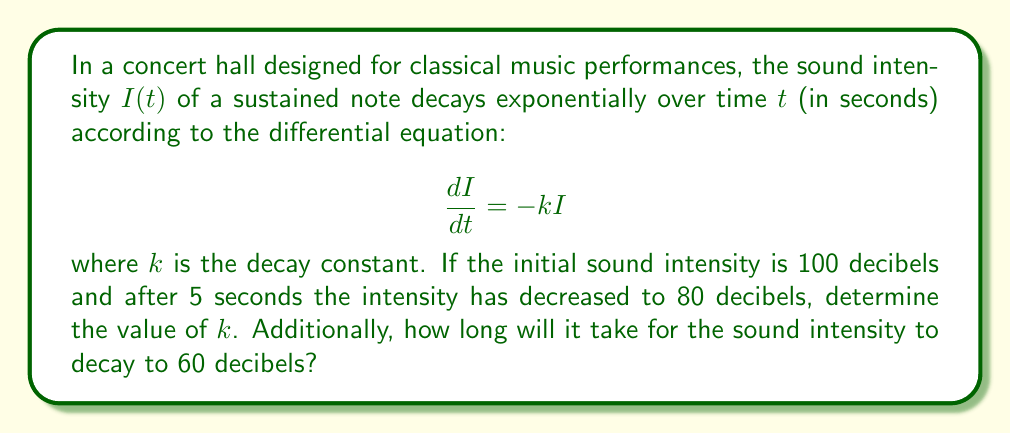Provide a solution to this math problem. Let's solve this problem step by step:

1) The general solution to the differential equation $\frac{dI}{dt} = -kI$ is:

   $$I(t) = I_0e^{-kt}$$

   where $I_0$ is the initial intensity.

2) We're given that $I_0 = 100$ dB and $I(5) = 80$ dB. Let's substitute these into our equation:

   $$80 = 100e^{-5k}$$

3) Dividing both sides by 100:

   $$0.8 = e^{-5k}$$

4) Taking the natural logarithm of both sides:

   $$\ln(0.8) = -5k$$

5) Solving for $k$:

   $$k = -\frac{\ln(0.8)}{5} \approx 0.0446$$

6) Now that we have $k$, let's find the time $t$ when the intensity reaches 60 dB:

   $$60 = 100e^{-0.0446t}$$

7) Dividing both sides by 100:

   $$0.6 = e^{-0.0446t}$$

8) Taking the natural logarithm of both sides:

   $$\ln(0.6) = -0.0446t$$

9) Solving for $t$:

   $$t = -\frac{\ln(0.6)}{0.0446} \approx 11.47$$

Therefore, it will take approximately 11.47 seconds for the sound to decay to 60 dB.
Answer: $k \approx 0.0446$; $t \approx 11.47$ seconds 